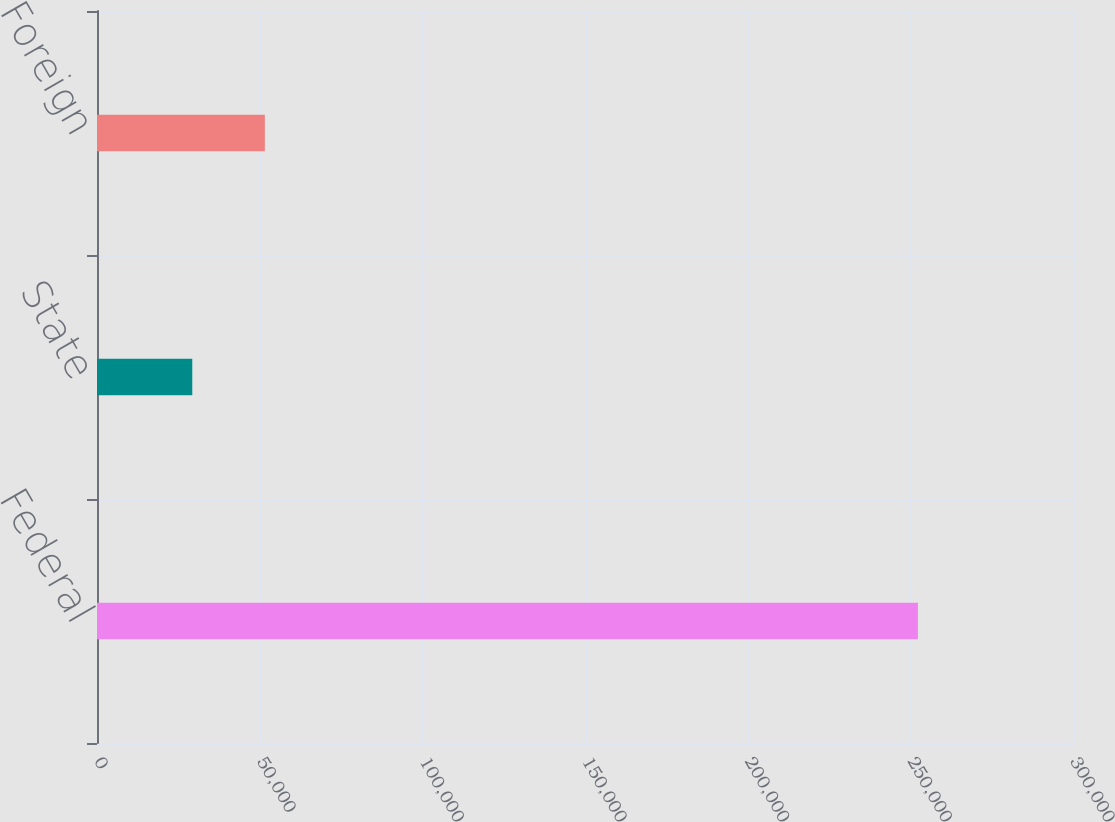<chart> <loc_0><loc_0><loc_500><loc_500><bar_chart><fcel>Federal<fcel>State<fcel>Foreign<nl><fcel>252337<fcel>29288<fcel>51592.9<nl></chart> 